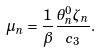Convert formula to latex. <formula><loc_0><loc_0><loc_500><loc_500>\mu _ { n } = \frac { 1 } { \beta } \frac { \theta ^ { 0 } _ { n } \zeta _ { n } } { c _ { 3 } } .</formula> 